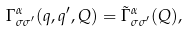<formula> <loc_0><loc_0><loc_500><loc_500>\Gamma ^ { \alpha } _ { \sigma \sigma ^ { \prime } } ( q , q ^ { \prime } , Q ) = \tilde { \Gamma } ^ { \alpha } _ { \sigma \sigma ^ { \prime } } ( Q ) ,</formula> 